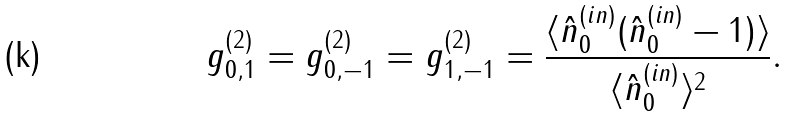<formula> <loc_0><loc_0><loc_500><loc_500>g _ { 0 , 1 } ^ { ( 2 ) } = g _ { 0 , - 1 } ^ { ( 2 ) } = g _ { 1 , - 1 } ^ { ( 2 ) } = \frac { \langle \hat { n } _ { 0 } ^ { ( i n ) } ( \hat { n } _ { 0 } ^ { ( i n ) } - 1 ) \rangle } { \langle \hat { n } _ { 0 } ^ { ( i n ) } \rangle ^ { 2 } } .</formula> 